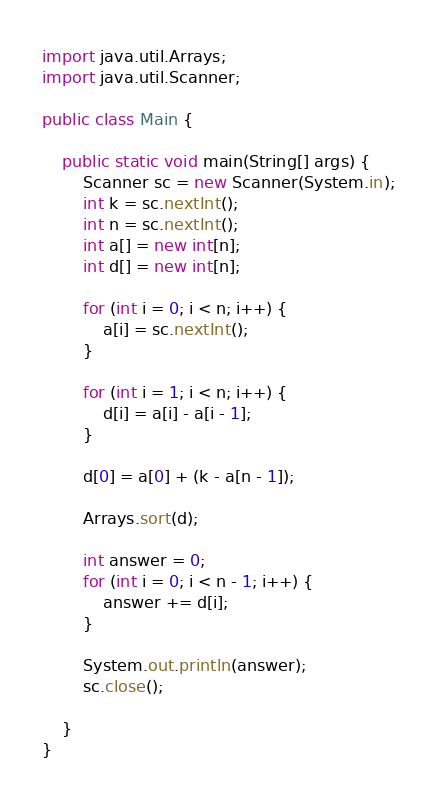Convert code to text. <code><loc_0><loc_0><loc_500><loc_500><_Java_>import java.util.Arrays;
import java.util.Scanner;

public class Main {

	public static void main(String[] args) {
		Scanner sc = new Scanner(System.in);
		int k = sc.nextInt();
		int n = sc.nextInt();
		int a[] = new int[n];
		int d[] = new int[n];

		for (int i = 0; i < n; i++) {
			a[i] = sc.nextInt();
		}

		for (int i = 1; i < n; i++) {
			d[i] = a[i] - a[i - 1];
		}

		d[0] = a[0] + (k - a[n - 1]);

		Arrays.sort(d);

		int answer = 0;
		for (int i = 0; i < n - 1; i++) {
			answer += d[i];
		}

		System.out.println(answer);
		sc.close();

	}
}</code> 